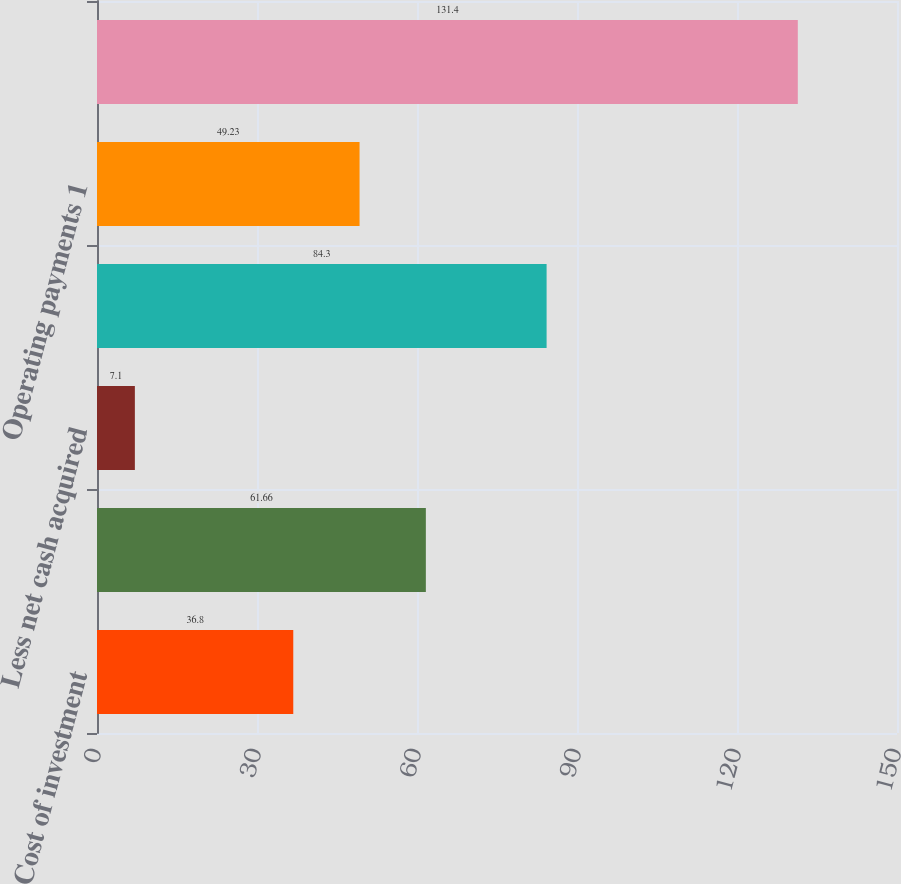Convert chart. <chart><loc_0><loc_0><loc_500><loc_500><bar_chart><fcel>Cost of investment<fcel>Cost of investment prior-year<fcel>Less net cash acquired<fcel>Total cost of investment<fcel>Operating payments 1<fcel>Total cash paid for<nl><fcel>36.8<fcel>61.66<fcel>7.1<fcel>84.3<fcel>49.23<fcel>131.4<nl></chart> 